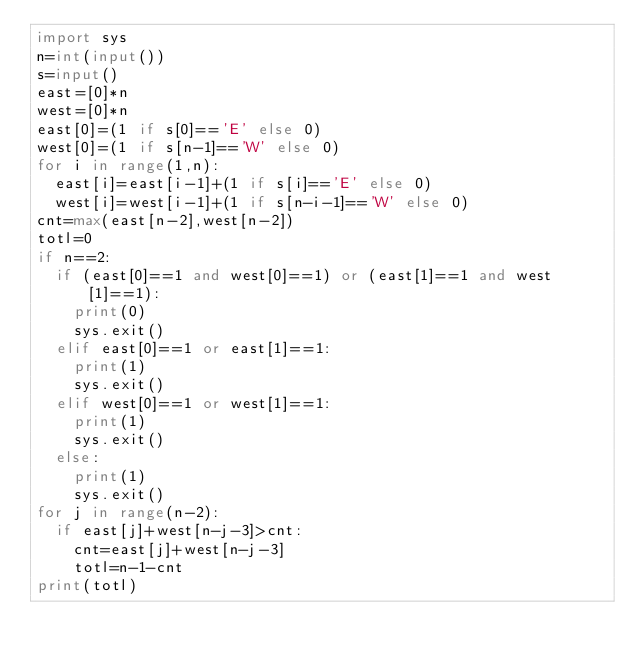<code> <loc_0><loc_0><loc_500><loc_500><_Python_>import sys
n=int(input())
s=input()
east=[0]*n
west=[0]*n
east[0]=(1 if s[0]=='E' else 0)
west[0]=(1 if s[n-1]=='W' else 0)
for i in range(1,n):
  east[i]=east[i-1]+(1 if s[i]=='E' else 0)
  west[i]=west[i-1]+(1 if s[n-i-1]=='W' else 0)
cnt=max(east[n-2],west[n-2])
totl=0
if n==2:
  if (east[0]==1 and west[0]==1) or (east[1]==1 and west[1]==1):
    print(0)
    sys.exit()
  elif east[0]==1 or east[1]==1:
    print(1)
    sys.exit()
  elif west[0]==1 or west[1]==1:
    print(1)
    sys.exit()
  else:
    print(1)
    sys.exit()
for j in range(n-2):
  if east[j]+west[n-j-3]>cnt:
    cnt=east[j]+west[n-j-3]
    totl=n-1-cnt
print(totl)
    
  
</code> 